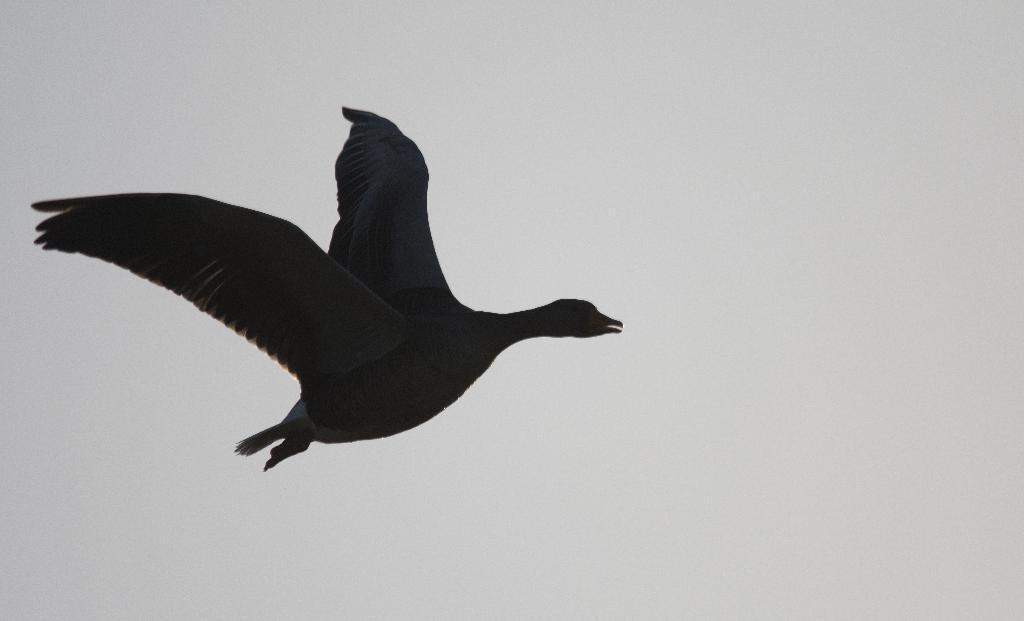Could you give a brief overview of what you see in this image? In this image we can see a bird in sky. 